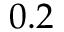Convert formula to latex. <formula><loc_0><loc_0><loc_500><loc_500>0 . 2</formula> 